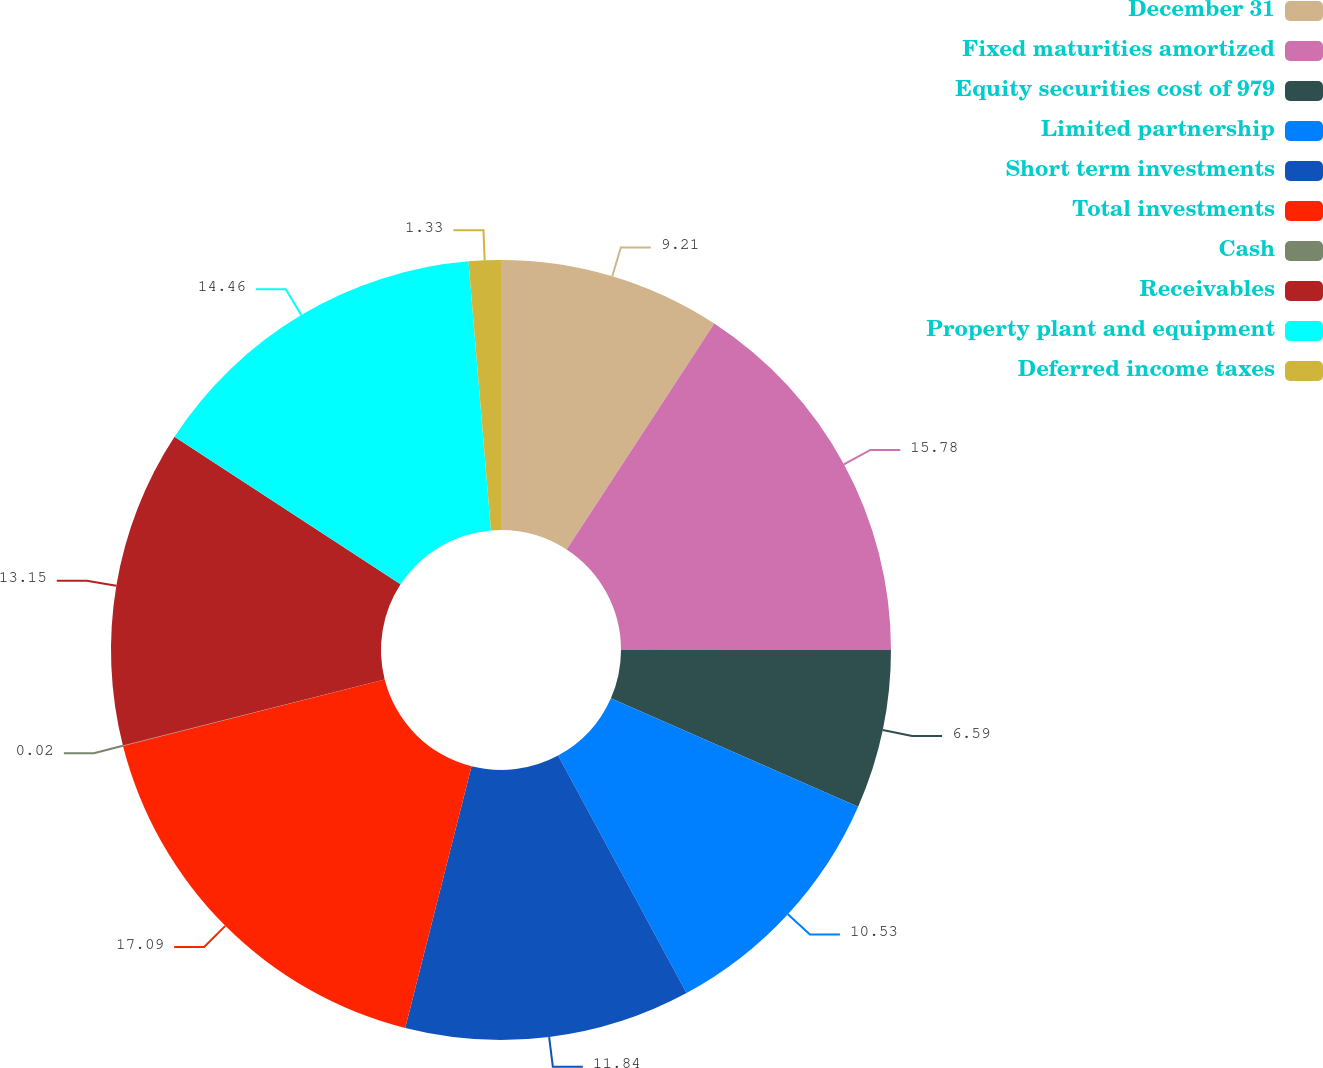Convert chart. <chart><loc_0><loc_0><loc_500><loc_500><pie_chart><fcel>December 31<fcel>Fixed maturities amortized<fcel>Equity securities cost of 979<fcel>Limited partnership<fcel>Short term investments<fcel>Total investments<fcel>Cash<fcel>Receivables<fcel>Property plant and equipment<fcel>Deferred income taxes<nl><fcel>9.21%<fcel>15.78%<fcel>6.59%<fcel>10.53%<fcel>11.84%<fcel>17.09%<fcel>0.02%<fcel>13.15%<fcel>14.46%<fcel>1.33%<nl></chart> 